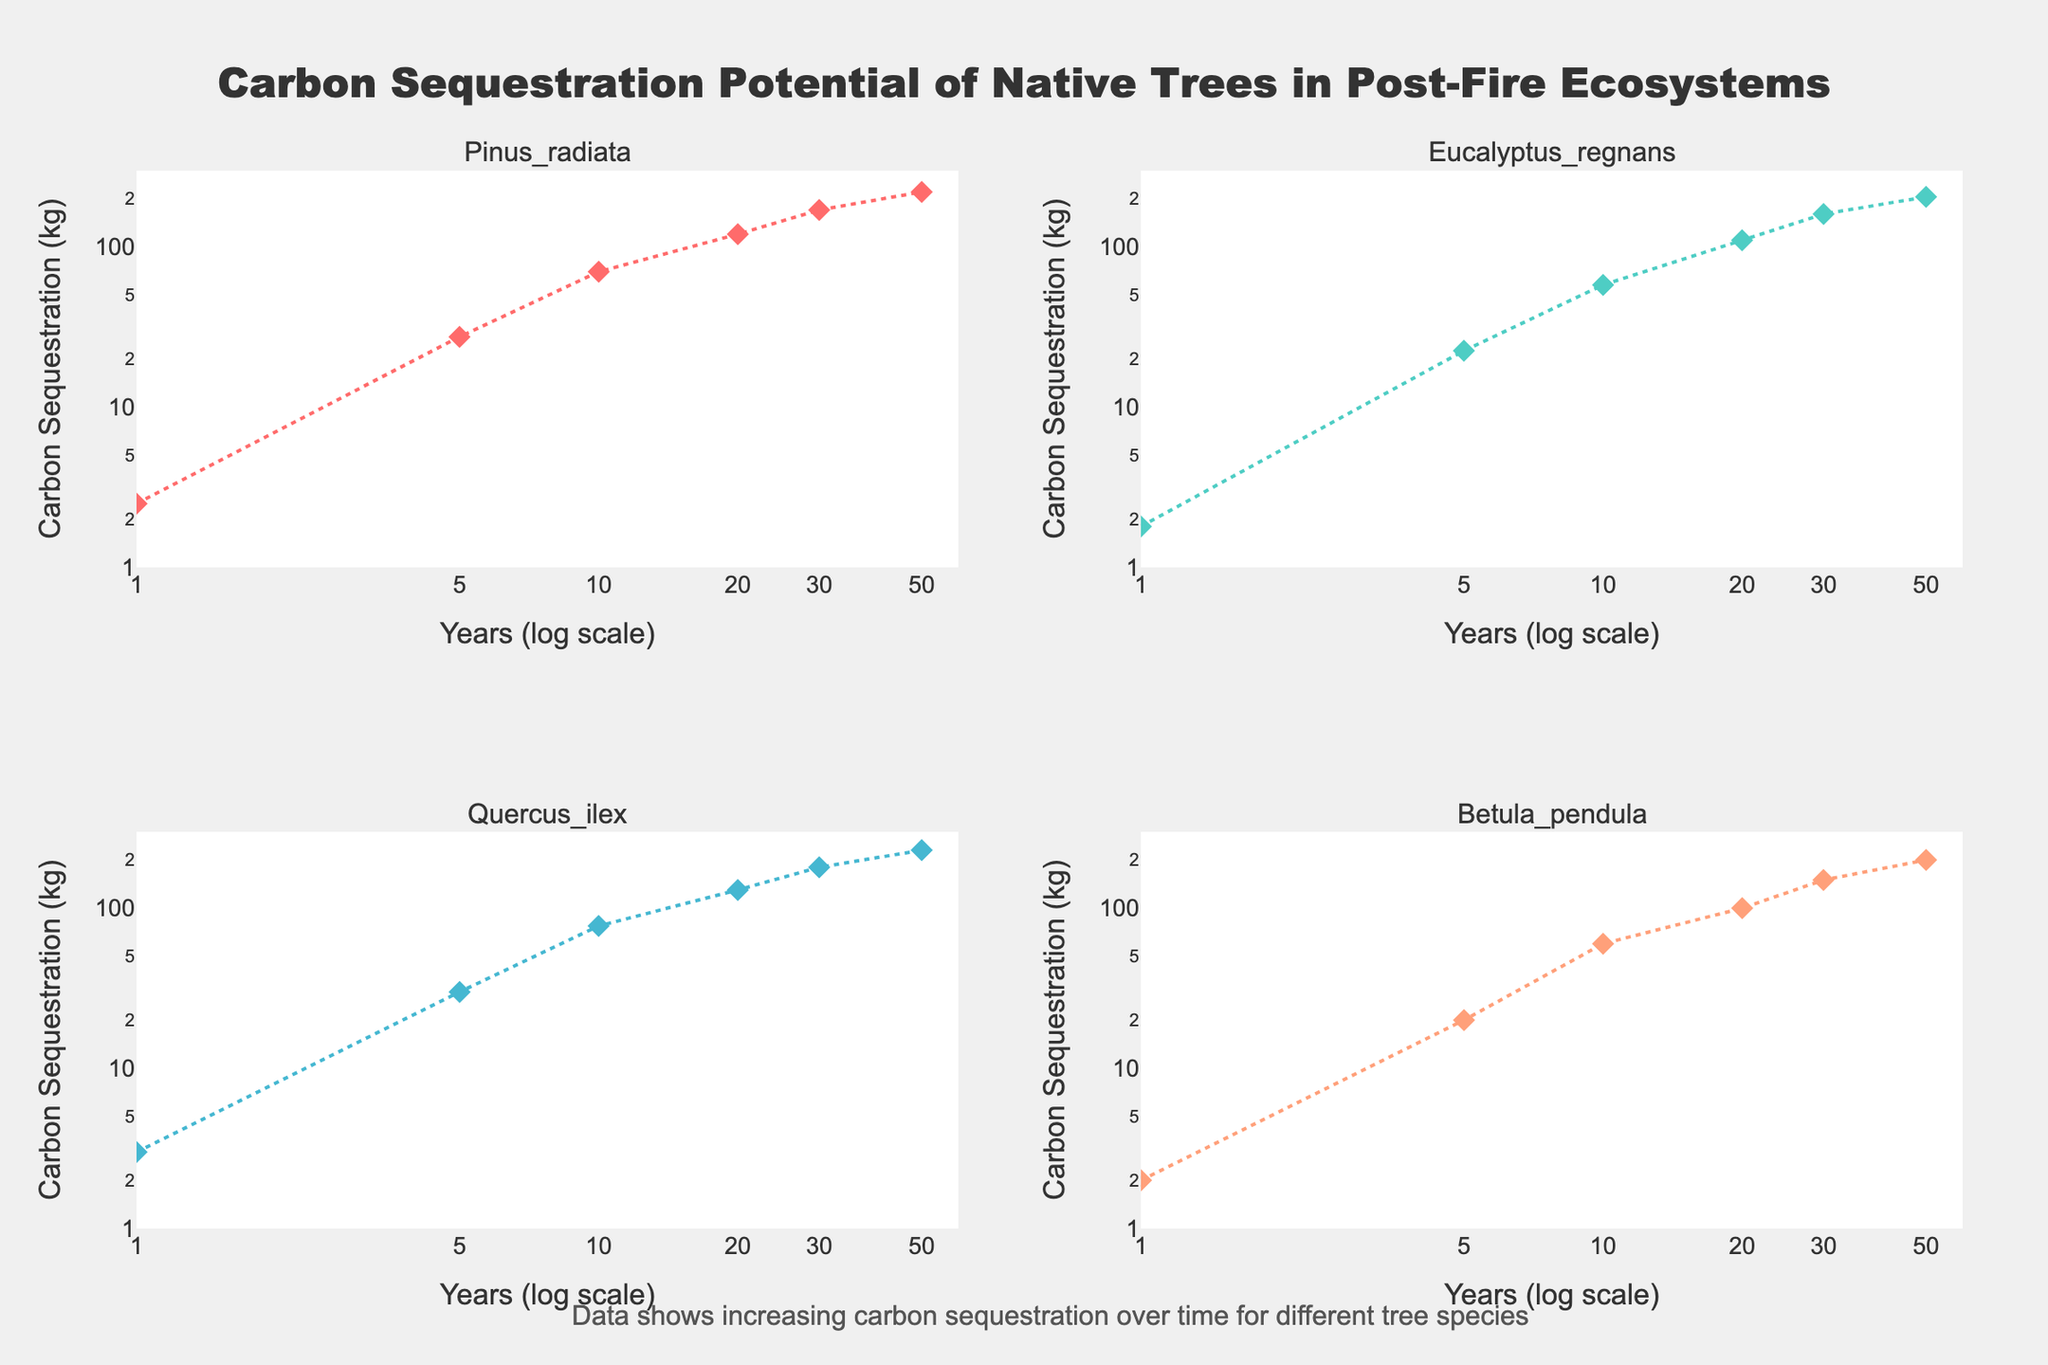What is the title of the plot? The title is prominently displayed at the top of the figure.
Answer: Carbon Sequestration Potential of Native Trees in Post-Fire Ecosystems How many species are shown in the figure? There are four subplot titles, each corresponding to a different species.
Answer: 4 Which species has the highest carbon sequestration after 50 years? By comparing the data points at the 50-year mark across all subplots, Pinus radiata shows the highest value.
Answer: Pinus radiata What does the x-axis represent? Each subplot's x-axis is labeled 'Years (log scale)', indicating it represents time in years on a logarithmic scale.
Answer: Years (log scale) In which year does Quercus ilex first reach a carbon sequestration of 30 kg? By following the trend line for Quercus ilex, it first intersects the 30 kg mark at 5 years.
Answer: 5 years Between Eucalyptus regnans and Betula pendula, which species has a higher carbon sequestration at 20 years? By comparing the 20-year data points for both species, Eucalyptus regnans has a higher value (110.2 kg) compared to Betula pendula (100 kg).
Answer: Eucalyptus regnans How does the trend of carbon sequestration change over time for Pinus radiata? The plot for Pinus radiata shows an increasing trend, where carbon sequestration rises substantially as the years progress on a logarithmic scale.
Answer: Increasing Are the y-axes labeled the same across all subplots? By examining each subplot, it can be seen that all y-axes are labeled 'Carbon Sequestration (kg)'.
Answer: Yes What is the purpose of the annotation below the plot? The annotation explains that the data illustrates increasing carbon sequestration over time for different tree species.
Answer: To explain the data trends Which species has the steepest increase in carbon sequestration between 1 and 5 years? By comparing the slopes of the lines between 1 and 5 years in each subplot, Quercus ilex has the steepest change from 3.0 kg to 30.0 kg.
Answer: Quercus ilex 